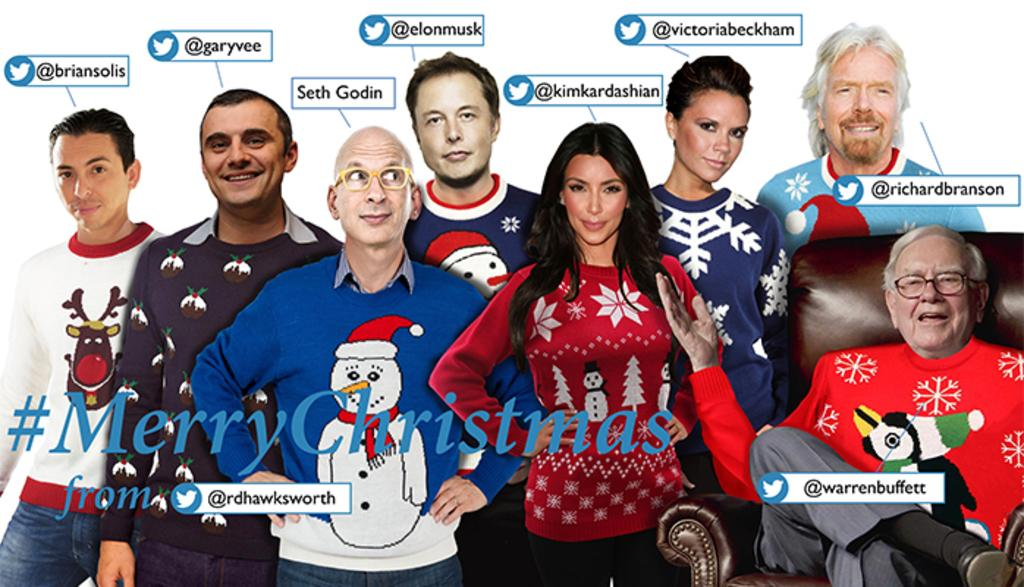<image>
Offer a succinct explanation of the picture presented. Collage of many celebrities and the word Merry Christmas in the front. 